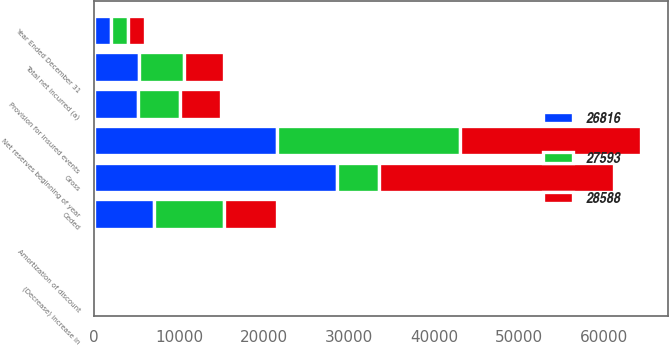Convert chart to OTSL. <chart><loc_0><loc_0><loc_500><loc_500><stacked_bar_chart><ecel><fcel>Year Ended December 31<fcel>Gross<fcel>Ceded<fcel>Net reserves beginning of year<fcel>Provision for insured events<fcel>(Decrease) increase in<fcel>Amortization of discount<fcel>Total net incurred (a)<nl><fcel>28588<fcel>2009<fcel>27593<fcel>6288<fcel>21305<fcel>4793<fcel>240<fcel>122<fcel>4675<nl><fcel>26816<fcel>2008<fcel>28588<fcel>7056<fcel>21532<fcel>5193<fcel>5<fcel>123<fcel>5311<nl><fcel>27593<fcel>2007<fcel>4939<fcel>8191<fcel>21445<fcel>4939<fcel>231<fcel>120<fcel>5290<nl></chart> 